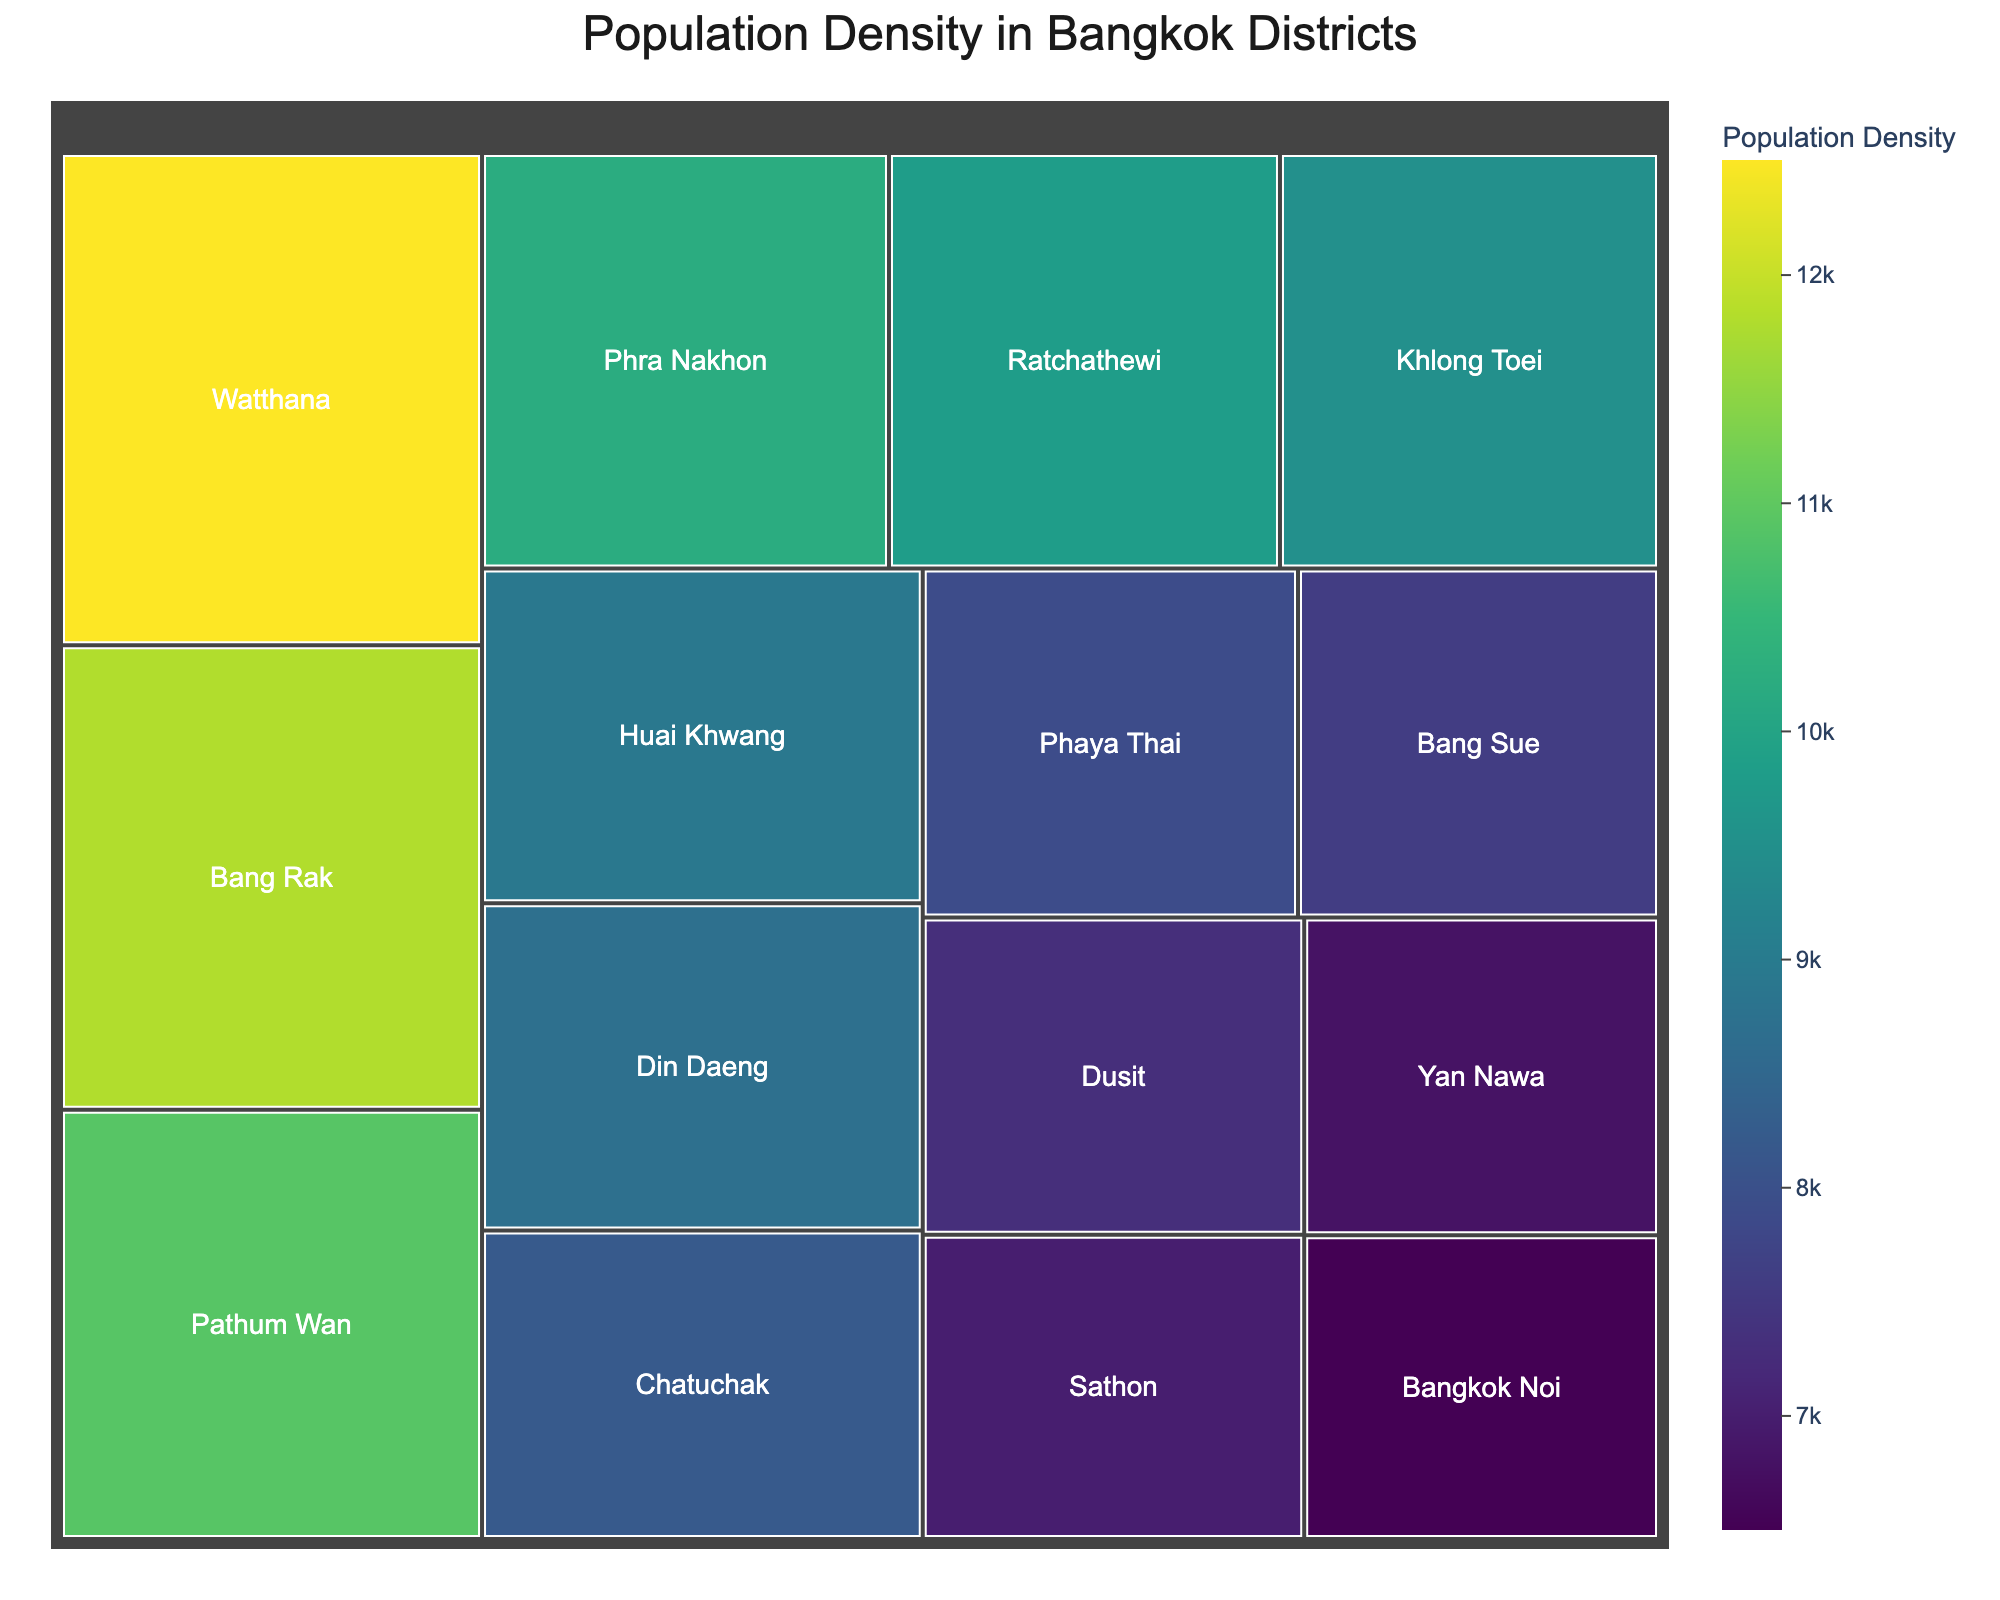What's the title of the figure? The title is displayed prominently at the top of the treemap, centering the theme of the visualization.
Answer: Population Density in Bangkok Districts Which district has the highest population density? The district with the largest area and the darkest color in the treemap represents the highest population density.
Answer: Watthana Compare the population densities of Watthana and Chatuchak. Which one is higher, and by how much? By comparing the values, Watthana has a population density of 12500 people/km², while Chatuchak has 8200 people/km². Subtracting the densities gives the difference.
Answer: Watthana is higher by 4300 people/km² What is the range of population densities among the districts? The range is found by subtracting the lowest population density in the data from the highest. The highest is 12500 (Watthana) and the lowest is 6500 (Bangkok Noi).
Answer: 6000 people/km² Find the average population density of Phra Nakhon, Ratchathewi, and Khlong Toei. Sum the population densities of these districts and divide by the number of districts: (10200 + 9800 + 9500) / 3.
Answer: 9833.33 people/km² Which district has a population density closest to 10000 people/km²? By looking at the values, the district with population density closest to 10000 is Phra Nakhon with 10200.
Answer: Phra Nakhon Are there more districts with population densities above or below 8500 people/km²? Count all districts with population densities above and below 8500. There are 7 districts above and 8 districts below.
Answer: Below What color represents the higher population densities in the treemap? The treemap uses the Viridis color scale, where darker colors represent higher values.
Answer: Darker colors Calculate the total population density of the top 3 densest districts. Adding the population densities of the top 3 districts: 12500 (Watthana) + 11800 (Bang Rak) + 10900 (Pathum Wan).
Answer: 35200 people/km² Which district has a higher population density, Sathon or Dusit, and by what amount? By comparing values, Sathon has 7000 and Dusit has 7300. Then, subtract the densities to find the difference.
Answer: Dusit by 300 people/km² 